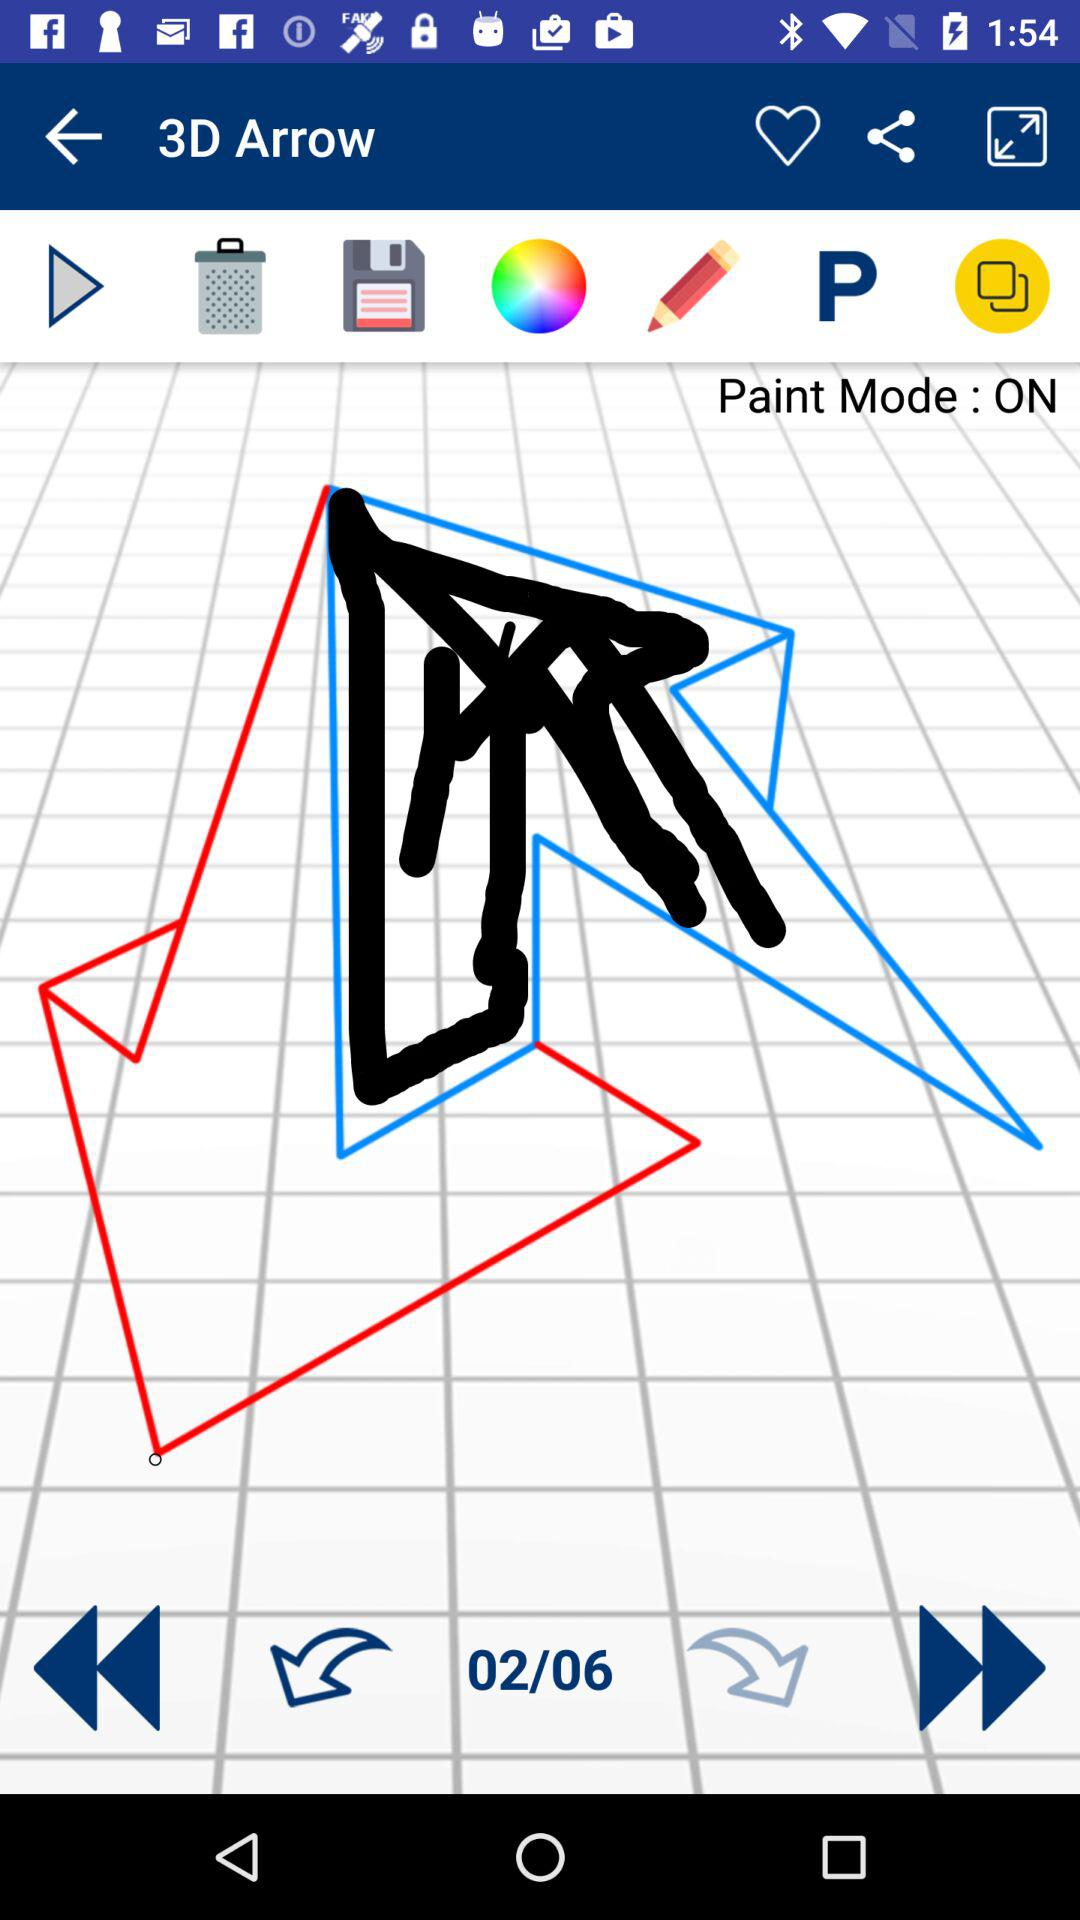What is the status of "Paint Mode"? The status is "on". 